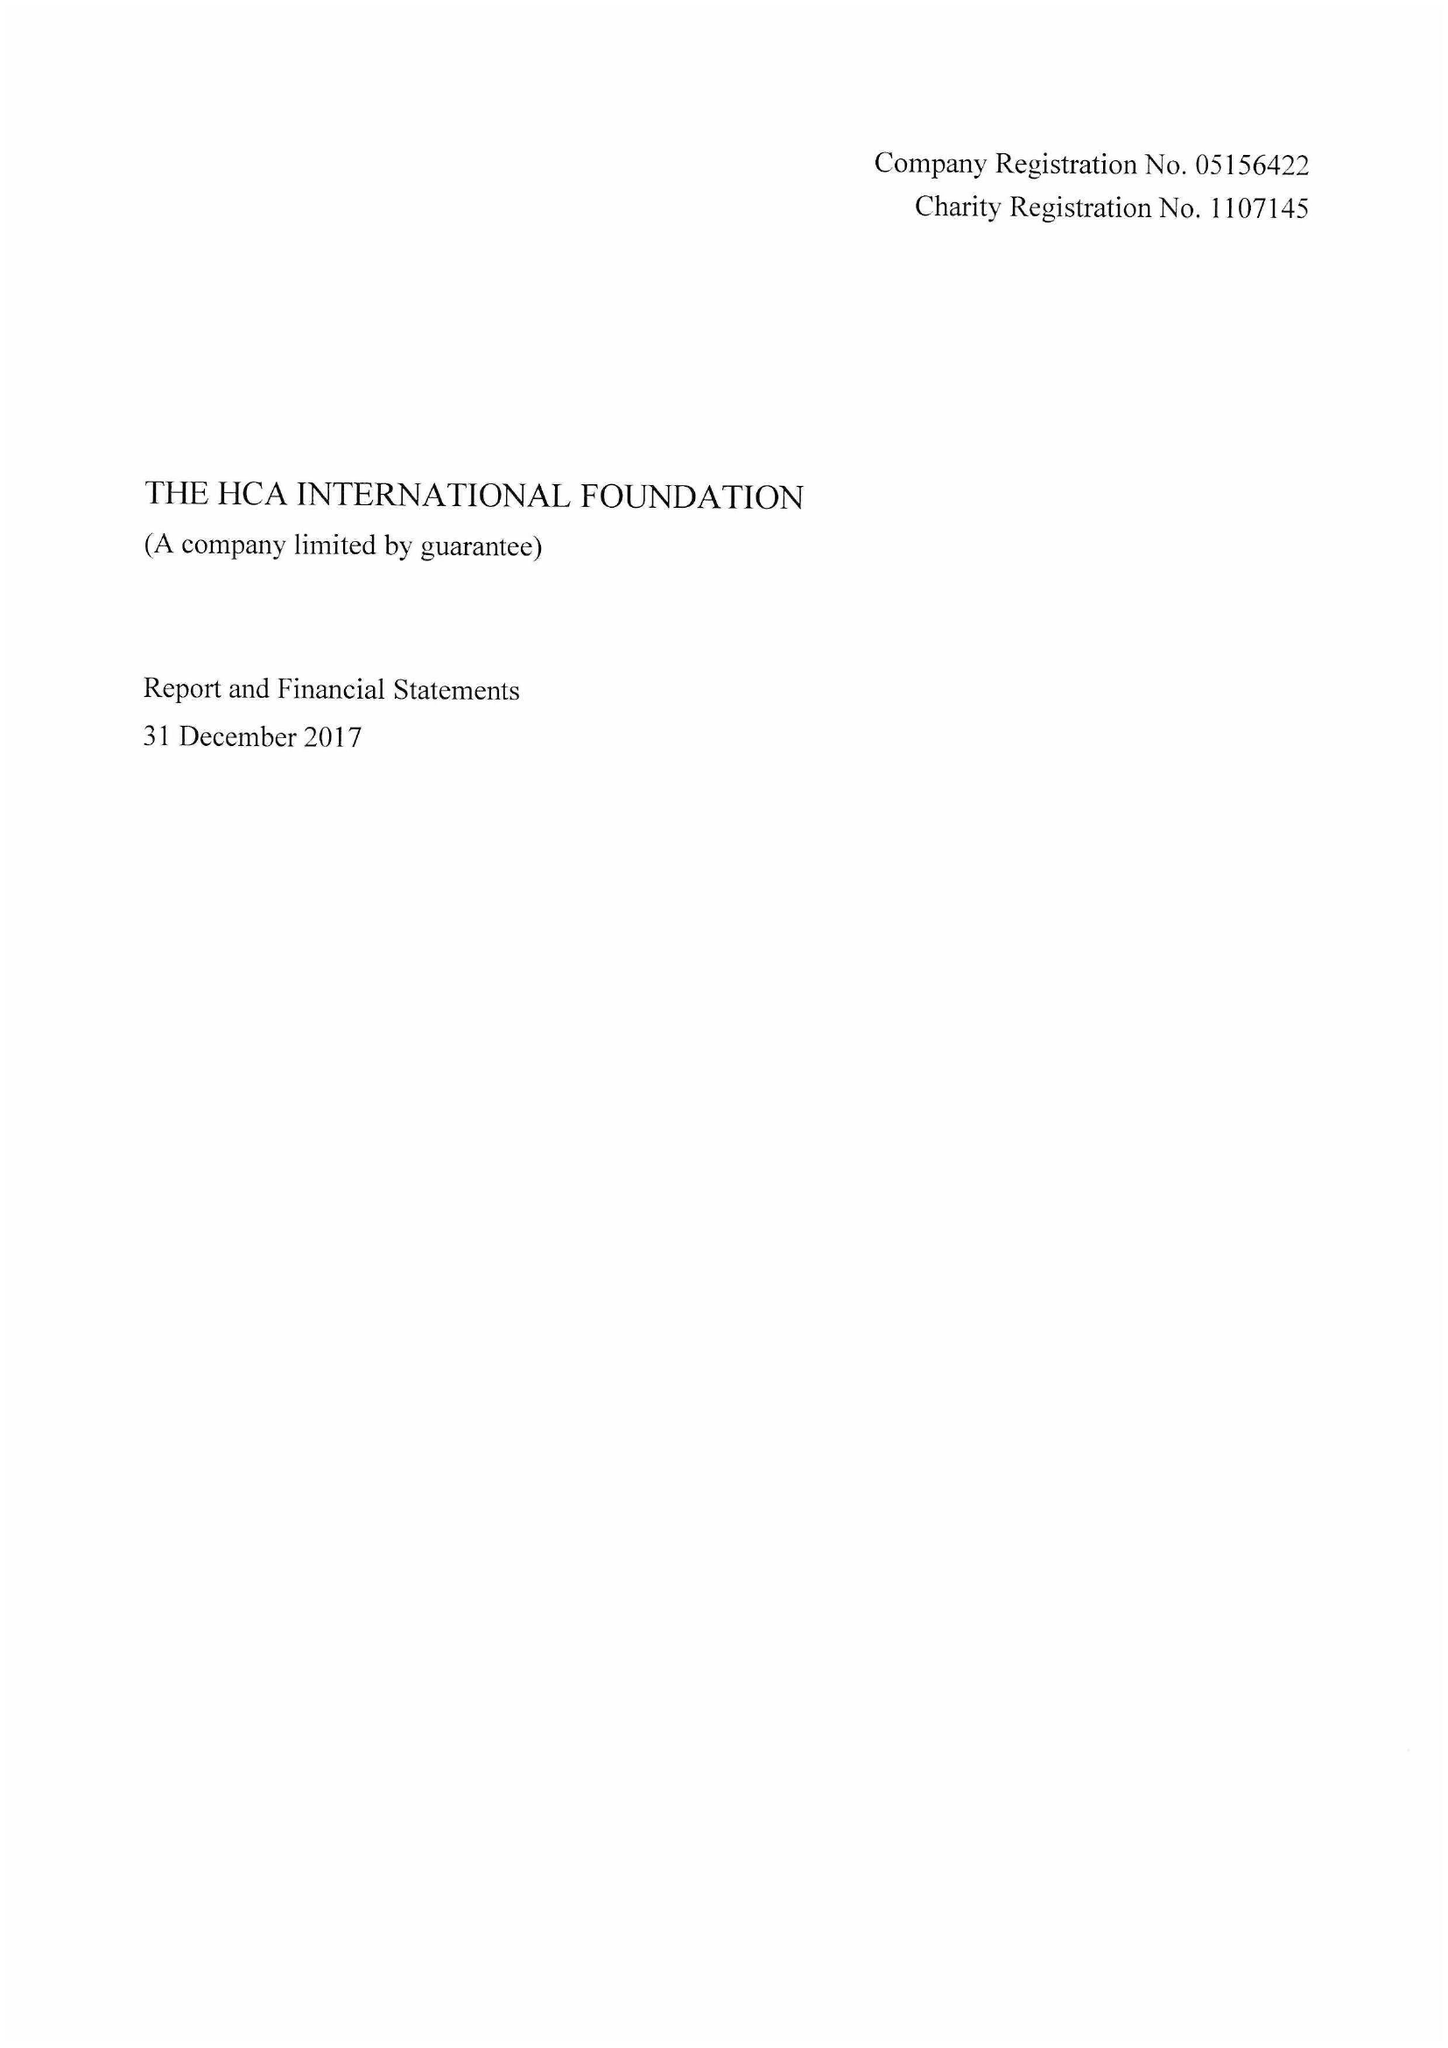What is the value for the report_date?
Answer the question using a single word or phrase. 2017-12-31 